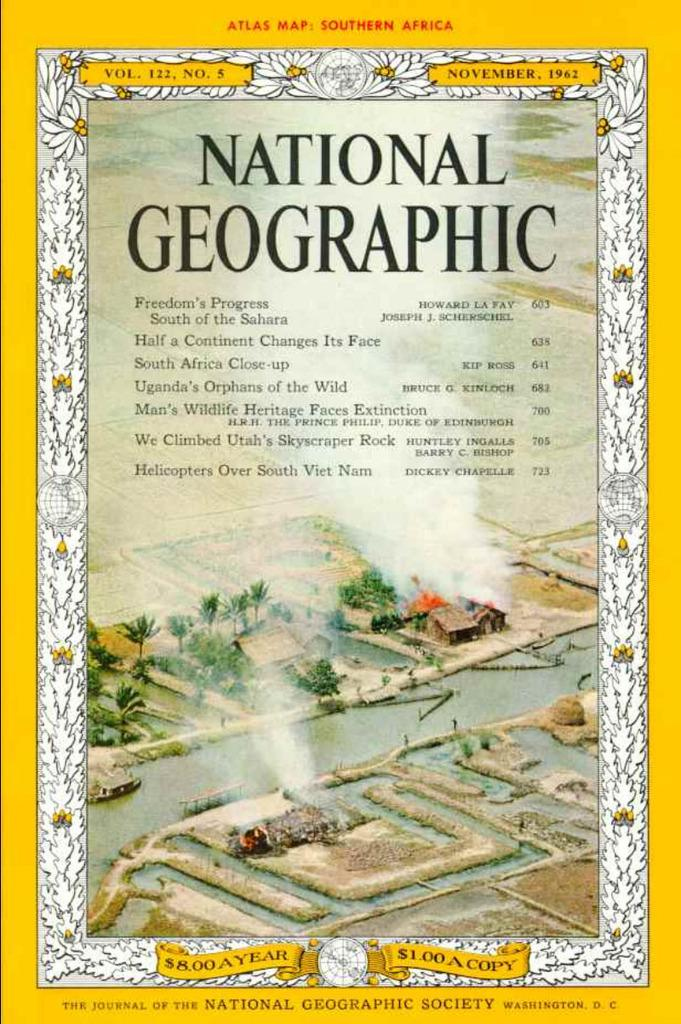<image>
Write a terse but informative summary of the picture. The November 1962 cover of National Geographic magazine. 